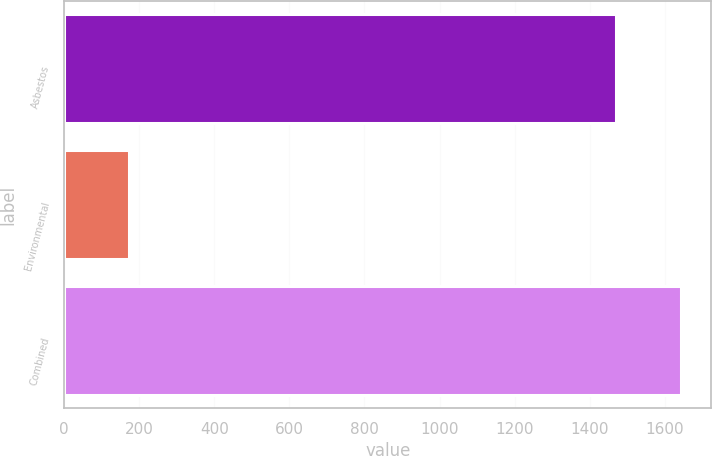Convert chart to OTSL. <chart><loc_0><loc_0><loc_500><loc_500><bar_chart><fcel>Asbestos<fcel>Environmental<fcel>Combined<nl><fcel>1469<fcel>173<fcel>1642<nl></chart> 